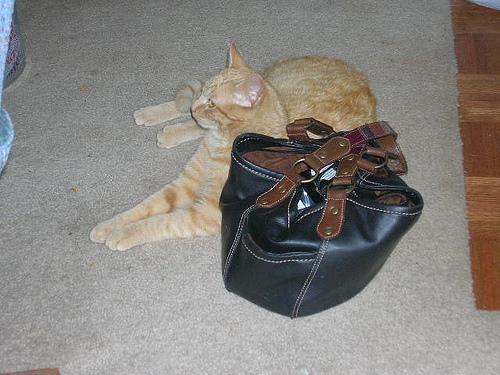Is this an adult cat?
Answer briefly. Yes. Is the cat guarding the purse?
Short answer required. No. Is the purse made of leather?
Short answer required. Yes. What color is the purse?
Give a very brief answer. Black. Is the bag empty?
Quick response, please. No. 